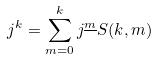<formula> <loc_0><loc_0><loc_500><loc_500>j ^ { k } = \sum _ { m = 0 } ^ { k } j ^ { \underline { m } } S ( k , m )</formula> 